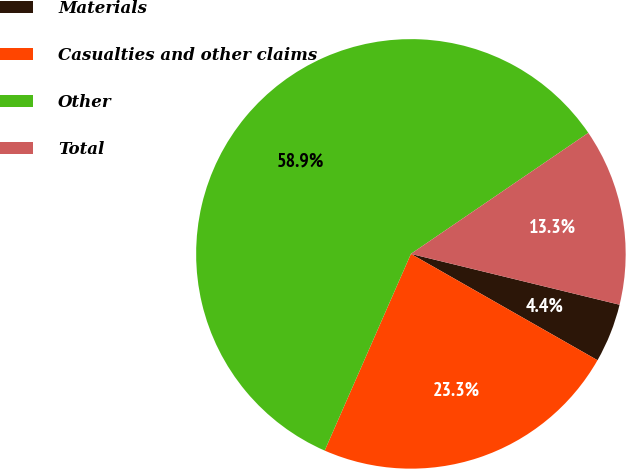Convert chart to OTSL. <chart><loc_0><loc_0><loc_500><loc_500><pie_chart><fcel>Materials<fcel>Casualties and other claims<fcel>Other<fcel>Total<nl><fcel>4.44%<fcel>23.33%<fcel>58.89%<fcel>13.33%<nl></chart> 